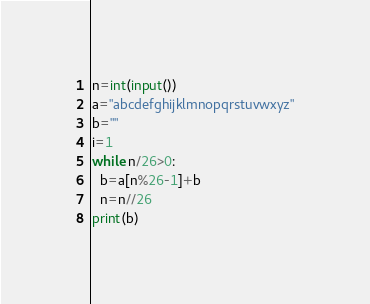Convert code to text. <code><loc_0><loc_0><loc_500><loc_500><_Python_>n=int(input())
a="abcdefghijklmnopqrstuvwxyz"
b=""
i=1
while n/26>0:
  b=a[n%26-1]+b
  n=n//26
print(b)</code> 